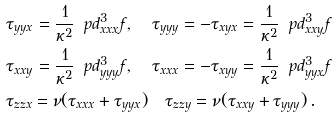Convert formula to latex. <formula><loc_0><loc_0><loc_500><loc_500>& \tau _ { y y x } = \frac { 1 } { \kappa ^ { 2 } } \, \ p d ^ { 3 } _ { x x x } f , \quad \tau _ { y y y } = - \tau _ { x y x } = \frac { 1 } { \kappa ^ { 2 } } \, \ p d ^ { 3 } _ { x x y } f \\ & \tau _ { x x y } = \frac { 1 } { \kappa ^ { 2 } } \, \ p d ^ { 3 } _ { y y y } f , \quad \tau _ { x x x } = - \tau _ { x y y } = \frac { 1 } { \kappa ^ { 2 } } \, \ p d ^ { 3 } _ { y y x } f \\ & \tau _ { z z x } = \nu ( \tau _ { x x x } + \tau _ { y y x } ) \quad \tau _ { z z y } = \nu ( \tau _ { x x y } + \tau _ { y y y } ) \, .</formula> 